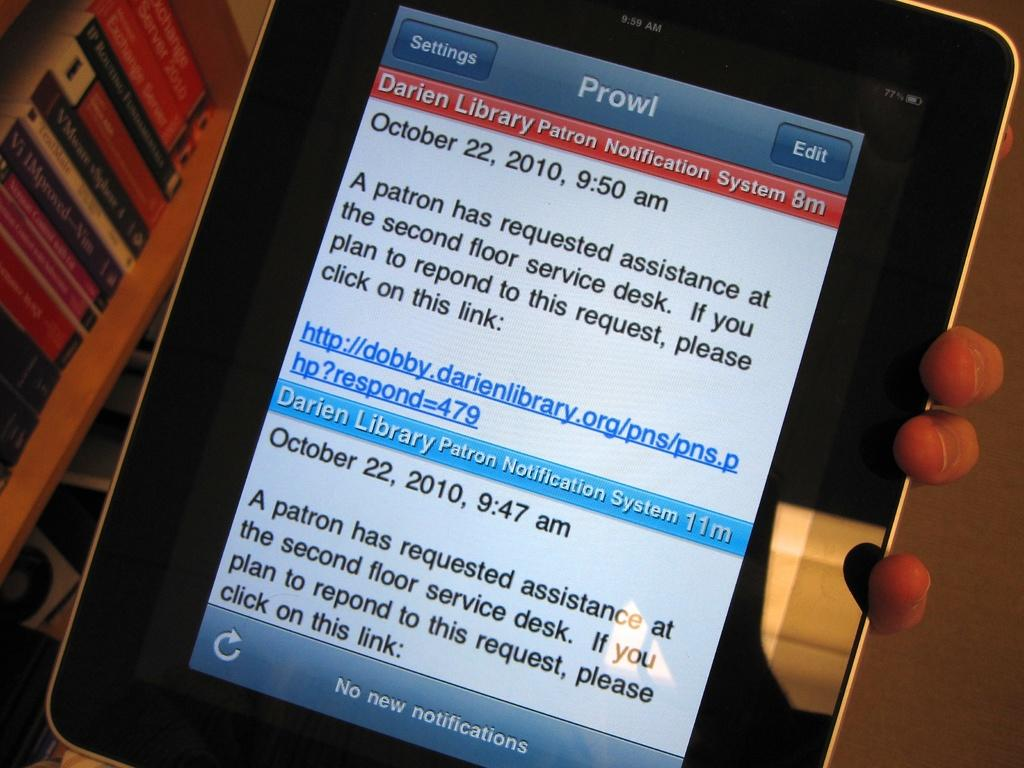<image>
Relay a brief, clear account of the picture shown. A tablet open to some sort of app that lets a worker know that a patron needs assistance at the second floor service desk. 